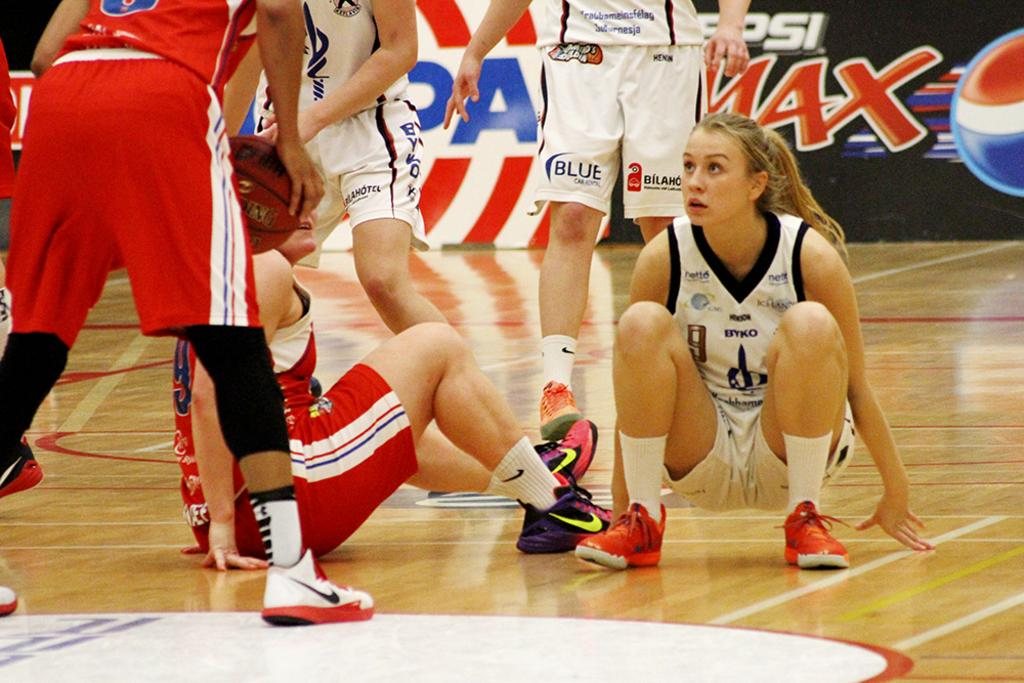<image>
Render a clear and concise summary of the photo. Women playing basketball with a Pepsi Max ad behind them. 